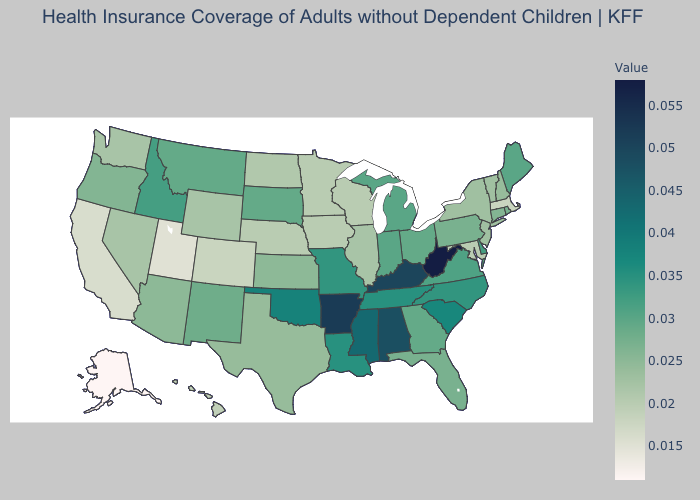Does Tennessee have a higher value than Ohio?
Short answer required. Yes. Does the map have missing data?
Write a very short answer. No. Among the states that border Maryland , does Virginia have the lowest value?
Answer briefly. No. Which states have the highest value in the USA?
Write a very short answer. West Virginia. Does Missouri have the lowest value in the USA?
Answer briefly. No. 